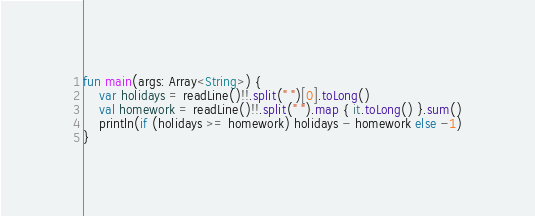<code> <loc_0><loc_0><loc_500><loc_500><_Kotlin_>fun main(args: Array<String>) {
    var holidays = readLine()!!.split(" ")[0].toLong()
    val homework = readLine()!!.split(" ").map { it.toLong() }.sum()
    println(if (holidays >= homework) holidays - homework else -1)
}</code> 